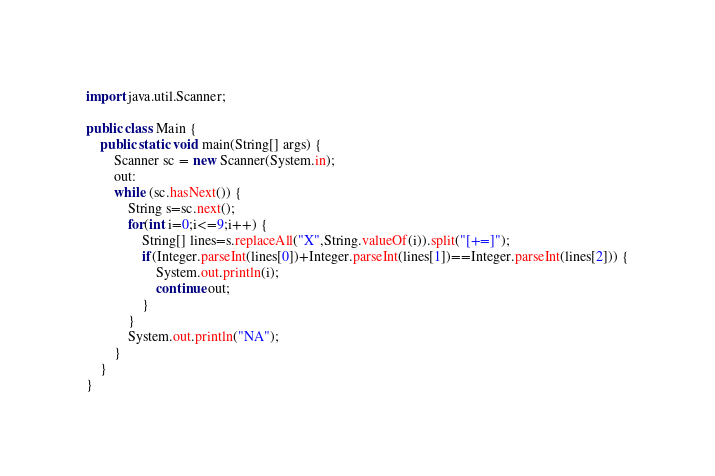Convert code to text. <code><loc_0><loc_0><loc_500><loc_500><_Java_>import java.util.Scanner;

public class Main {
    public static void main(String[] args) {
        Scanner sc = new Scanner(System.in);
        out:
        while (sc.hasNext()) {
            String s=sc.next();
            for(int i=0;i<=9;i++) {
                String[] lines=s.replaceAll("X",String.valueOf(i)).split("[+=]");
                if(Integer.parseInt(lines[0])+Integer.parseInt(lines[1])==Integer.parseInt(lines[2])) {
                    System.out.println(i);
                    continue out;
                }
            }
            System.out.println("NA");
        }
    }
}

</code> 